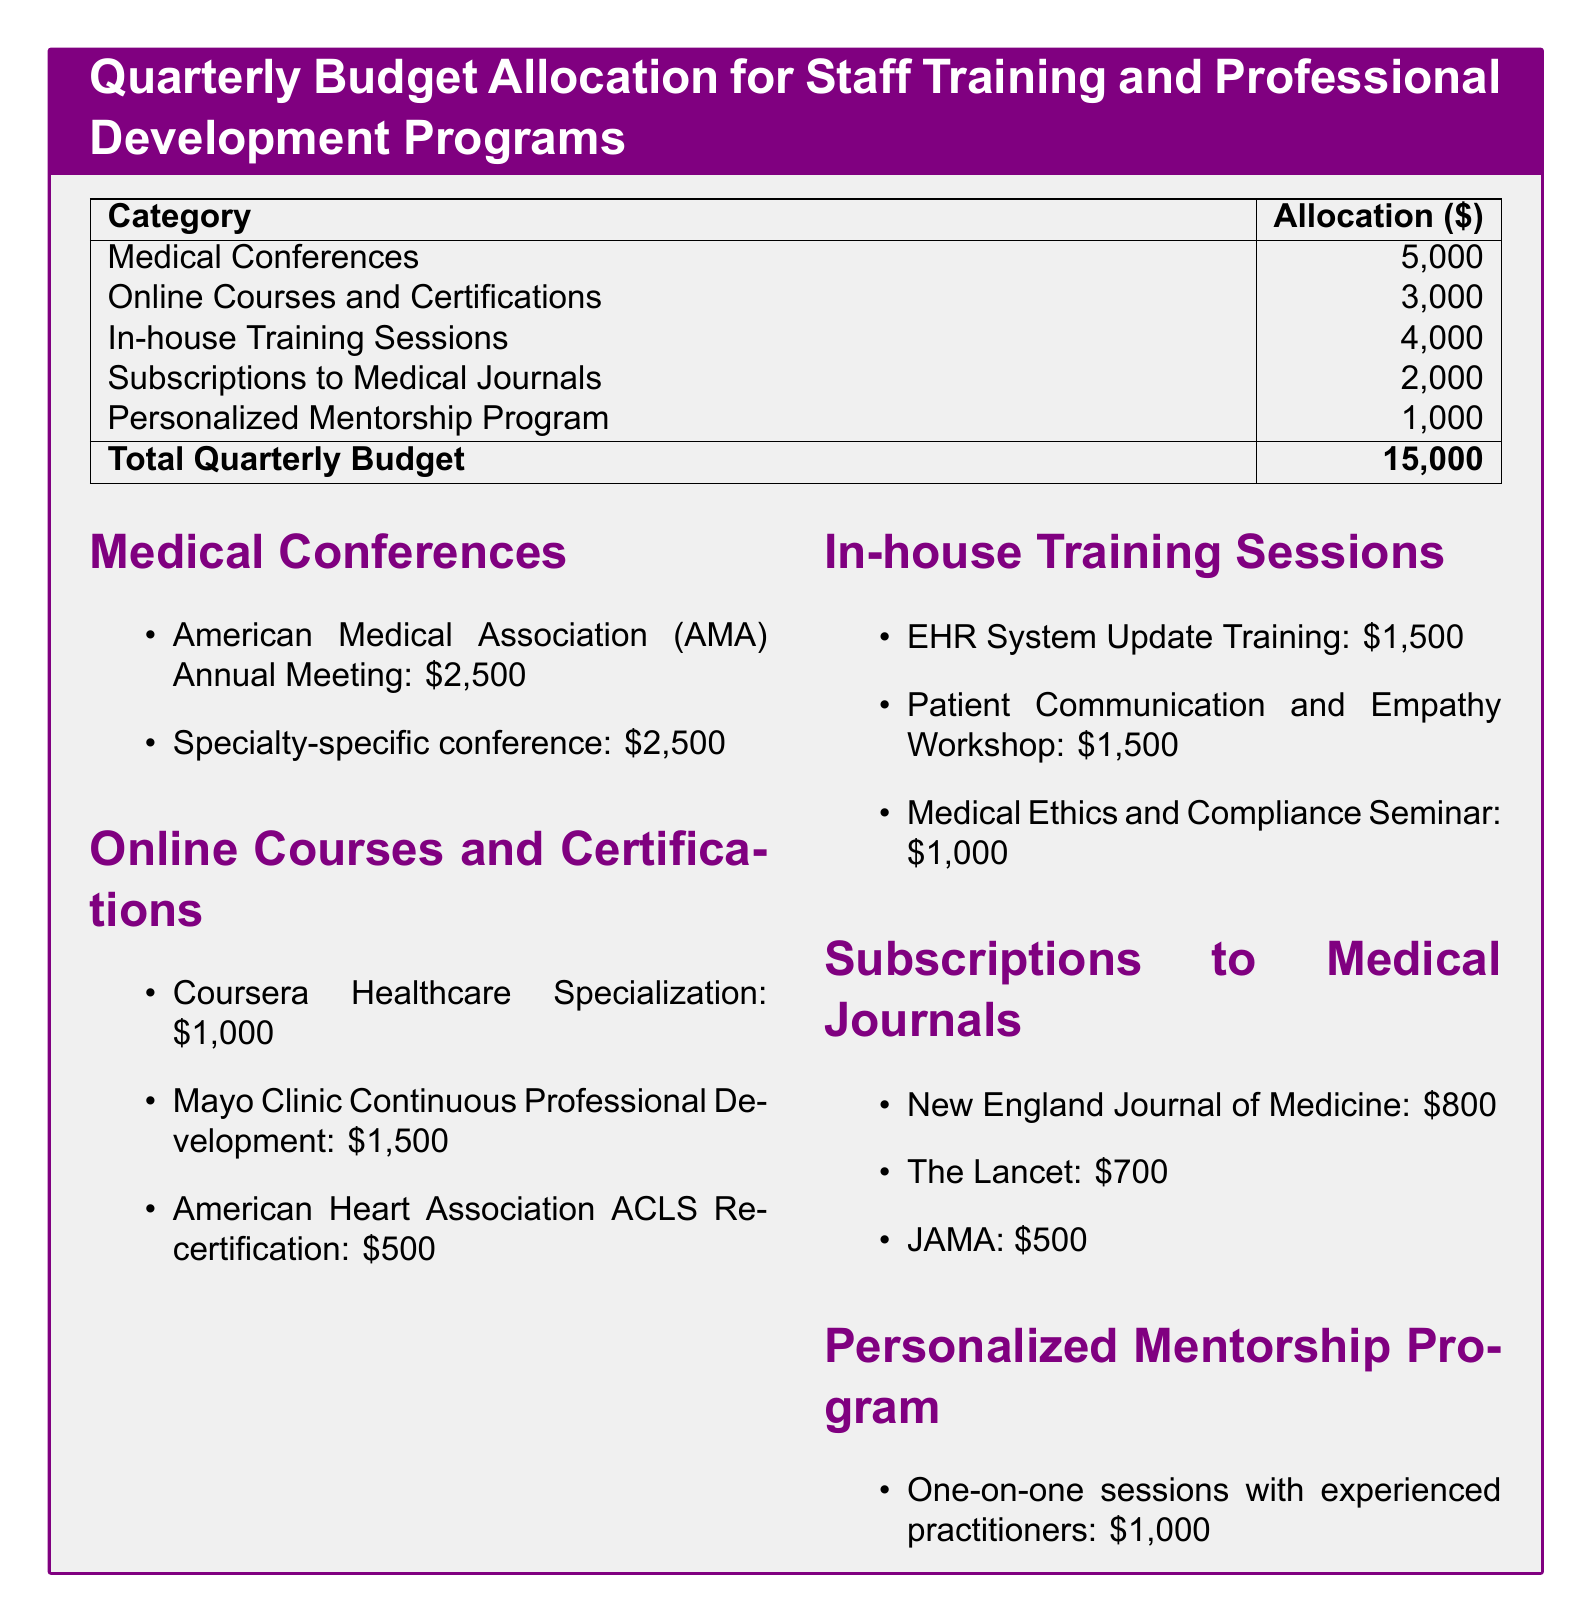what is the total quarterly budget? The total quarterly budget is listed at the bottom of the table and includes all allocated amounts, which total up to $15,000.
Answer: $15,000 how much is allocated for medical conferences? The document specifies that $5,000 is allocated for medical conferences, as indicated in the first row of the allocation table.
Answer: $5,000 what is the cost of the Mayo Clinic Continuous Professional Development course? The document lists the cost of the Mayo Clinic Continuous Professional Development course as $1,500 under the Online Courses and Certifications section.
Answer: $1,500 how many in-house training sessions are listed? There are three in-house training sessions mentioned under the In-house Training Sessions section, as enumerated in the document.
Answer: 3 what is the allocation for the Personalized Mentorship Program? The allocation for the Personalized Mentorship Program is specifically stated as $1,000 in the budget table.
Answer: $1,000 which journal costs $800 for a subscription? The New England Journal of Medicine is identified as the journal that costs $800 for a subscription in the document.
Answer: New England Journal of Medicine what is the budget allocated for online courses and certifications? The budget allocated for online courses and certifications is clearly listed as $3,000 in the allocation table within the document.
Answer: $3,000 how much will be spent on the Patient Communication and Empathy Workshop? The document shows that $1,500 is allocated for the Patient Communication and Empathy Workshop under the In-house Training Sessions section.
Answer: $1,500 whats the total amount for subscriptions to medical journals? The total allocated for subscriptions to medical journals can be calculated by adding the individual amounts of $800, $700, and $500, resulting in $2,000.
Answer: $2,000 